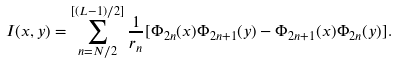Convert formula to latex. <formula><loc_0><loc_0><loc_500><loc_500>I ( x , y ) = \sum _ { n = N / 2 } ^ { [ ( L - 1 ) / 2 ] } \frac { 1 } { r _ { n } } [ \Phi _ { 2 n } ( x ) \Phi _ { 2 n + 1 } ( y ) - \Phi _ { 2 n + 1 } ( x ) \Phi _ { 2 n } ( y ) ] .</formula> 